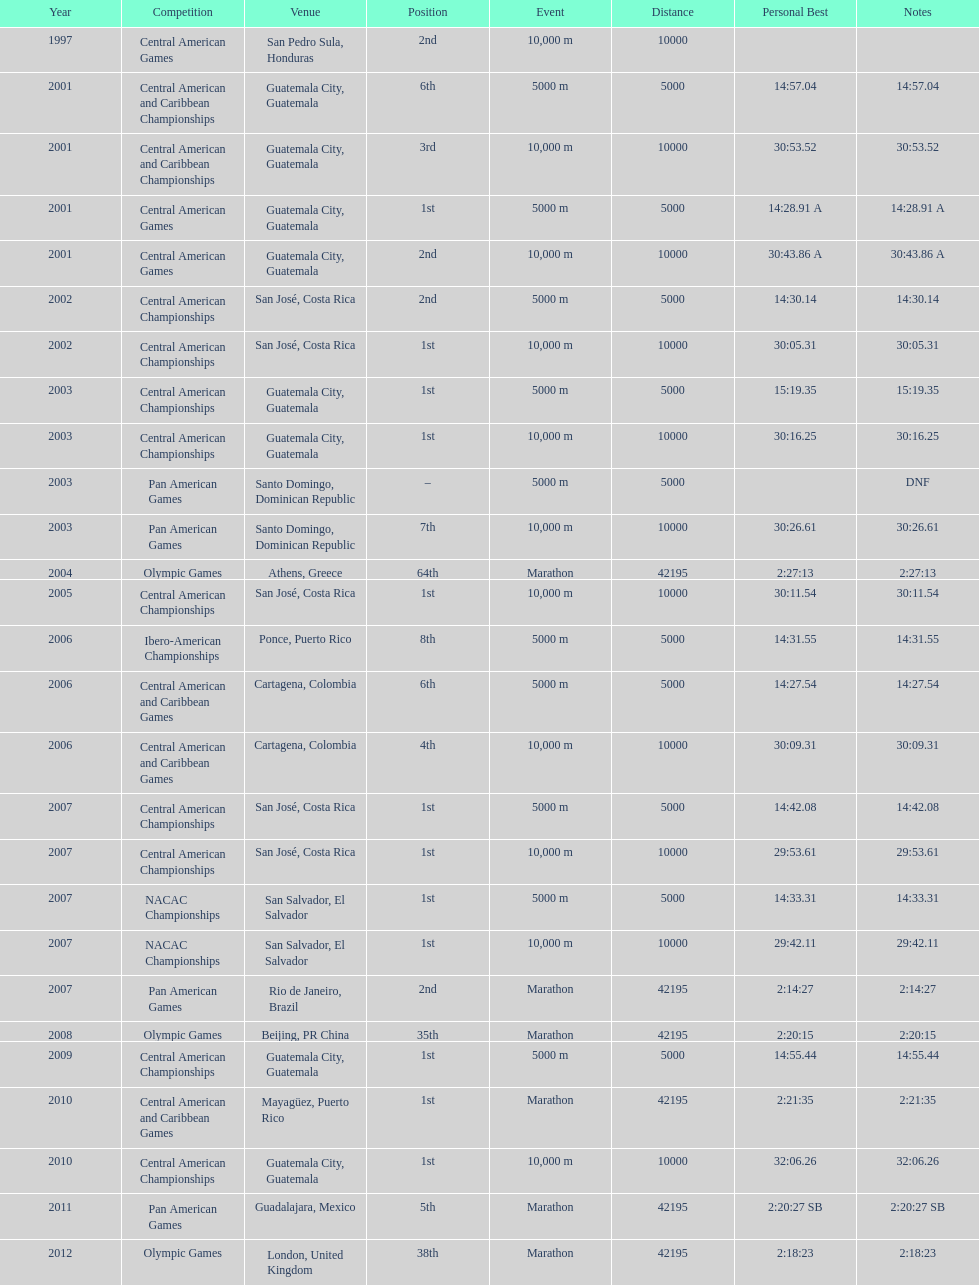The central american championships and what other competition occurred in 2010? Central American and Caribbean Games. 